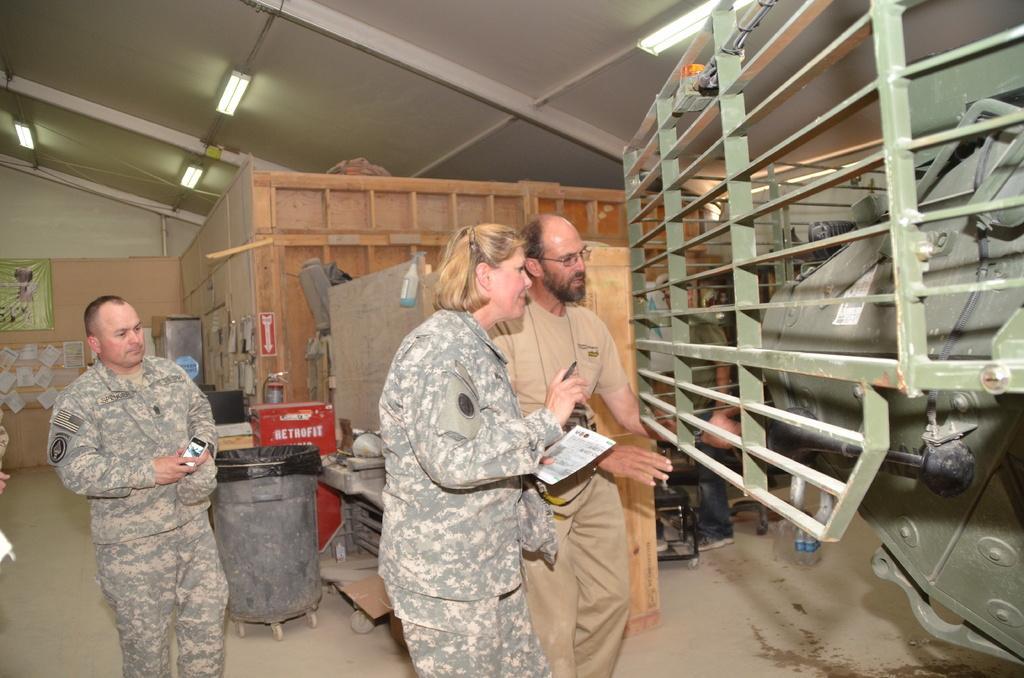Describe this image in one or two sentences. In this picture I can see there are three people standing here and one of them is a woman, she is holding a pen and a paper and on to right there is a military tank and there are lights attached to the ceiling. 